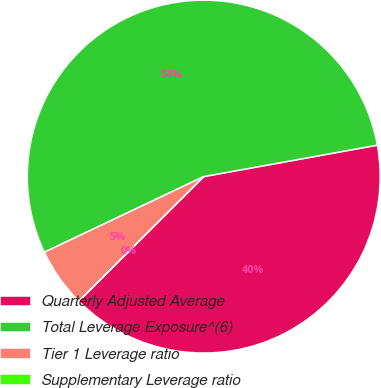<chart> <loc_0><loc_0><loc_500><loc_500><pie_chart><fcel>Quarterly Adjusted Average<fcel>Total Leverage Exposure^(6)<fcel>Tier 1 Leverage ratio<fcel>Supplementary Leverage ratio<nl><fcel>40.38%<fcel>54.2%<fcel>5.42%<fcel>0.0%<nl></chart> 